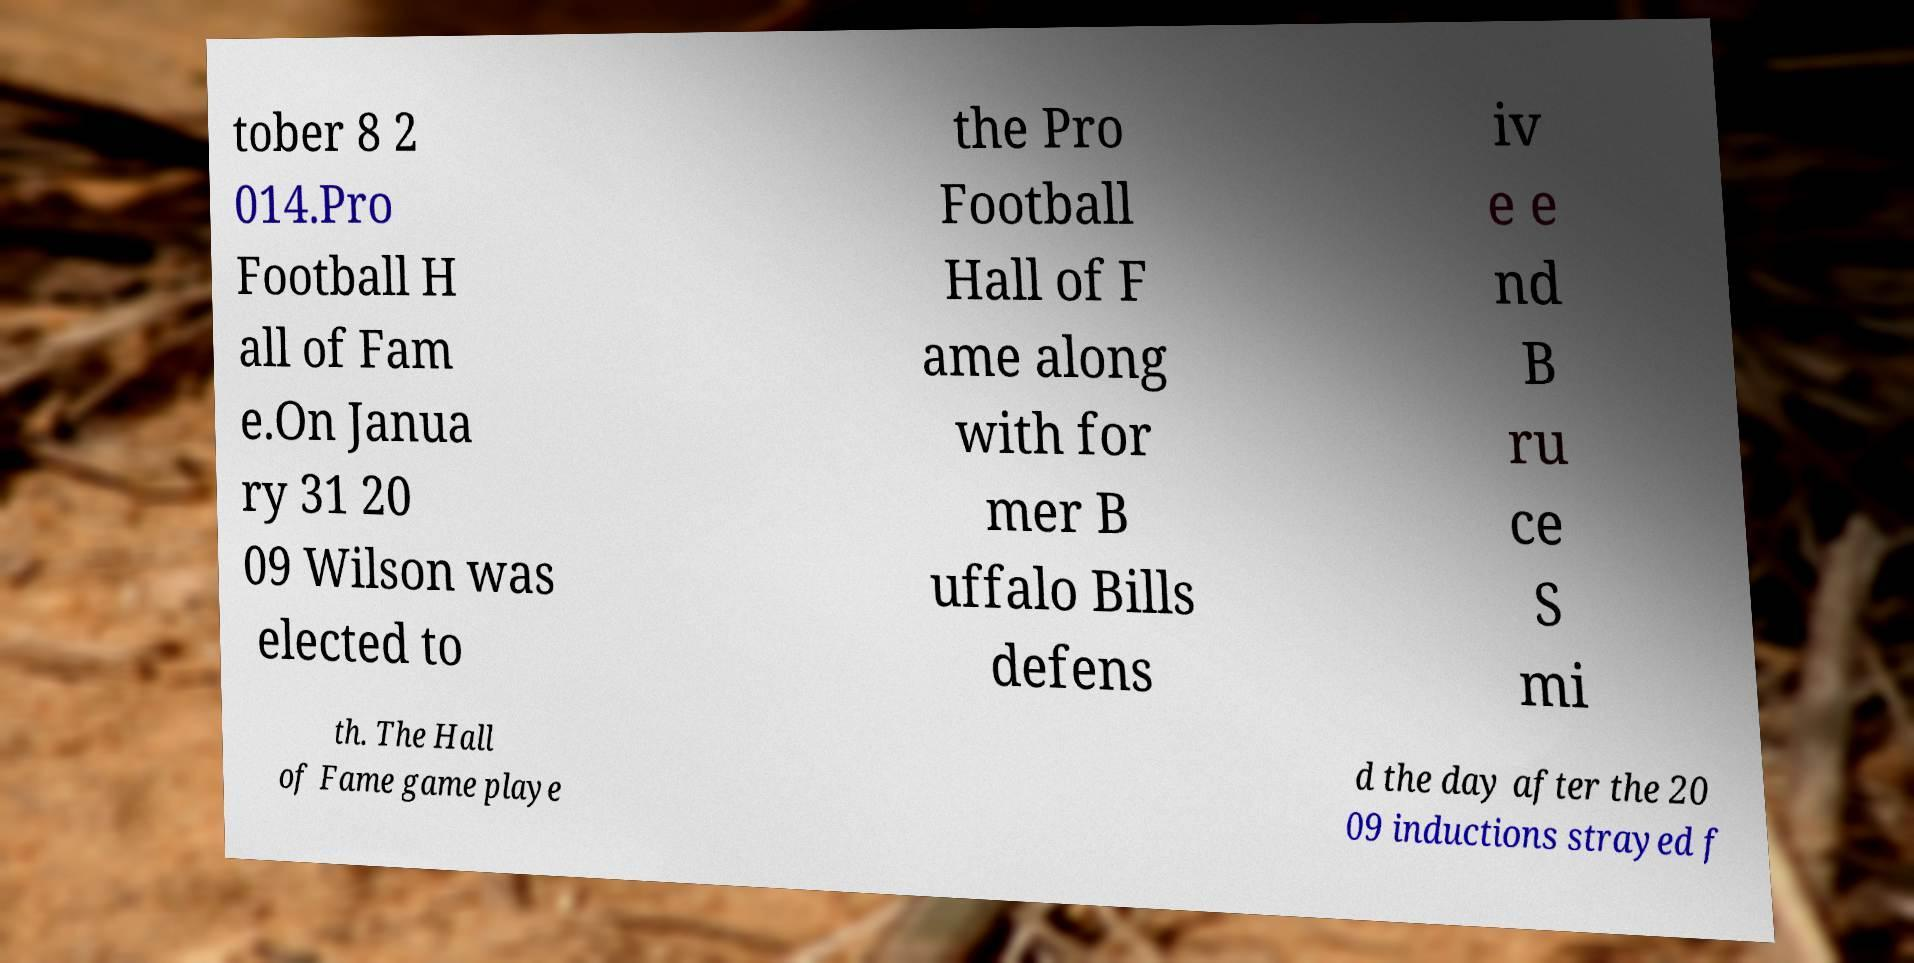Could you extract and type out the text from this image? tober 8 2 014.Pro Football H all of Fam e.On Janua ry 31 20 09 Wilson was elected to the Pro Football Hall of F ame along with for mer B uffalo Bills defens iv e e nd B ru ce S mi th. The Hall of Fame game playe d the day after the 20 09 inductions strayed f 